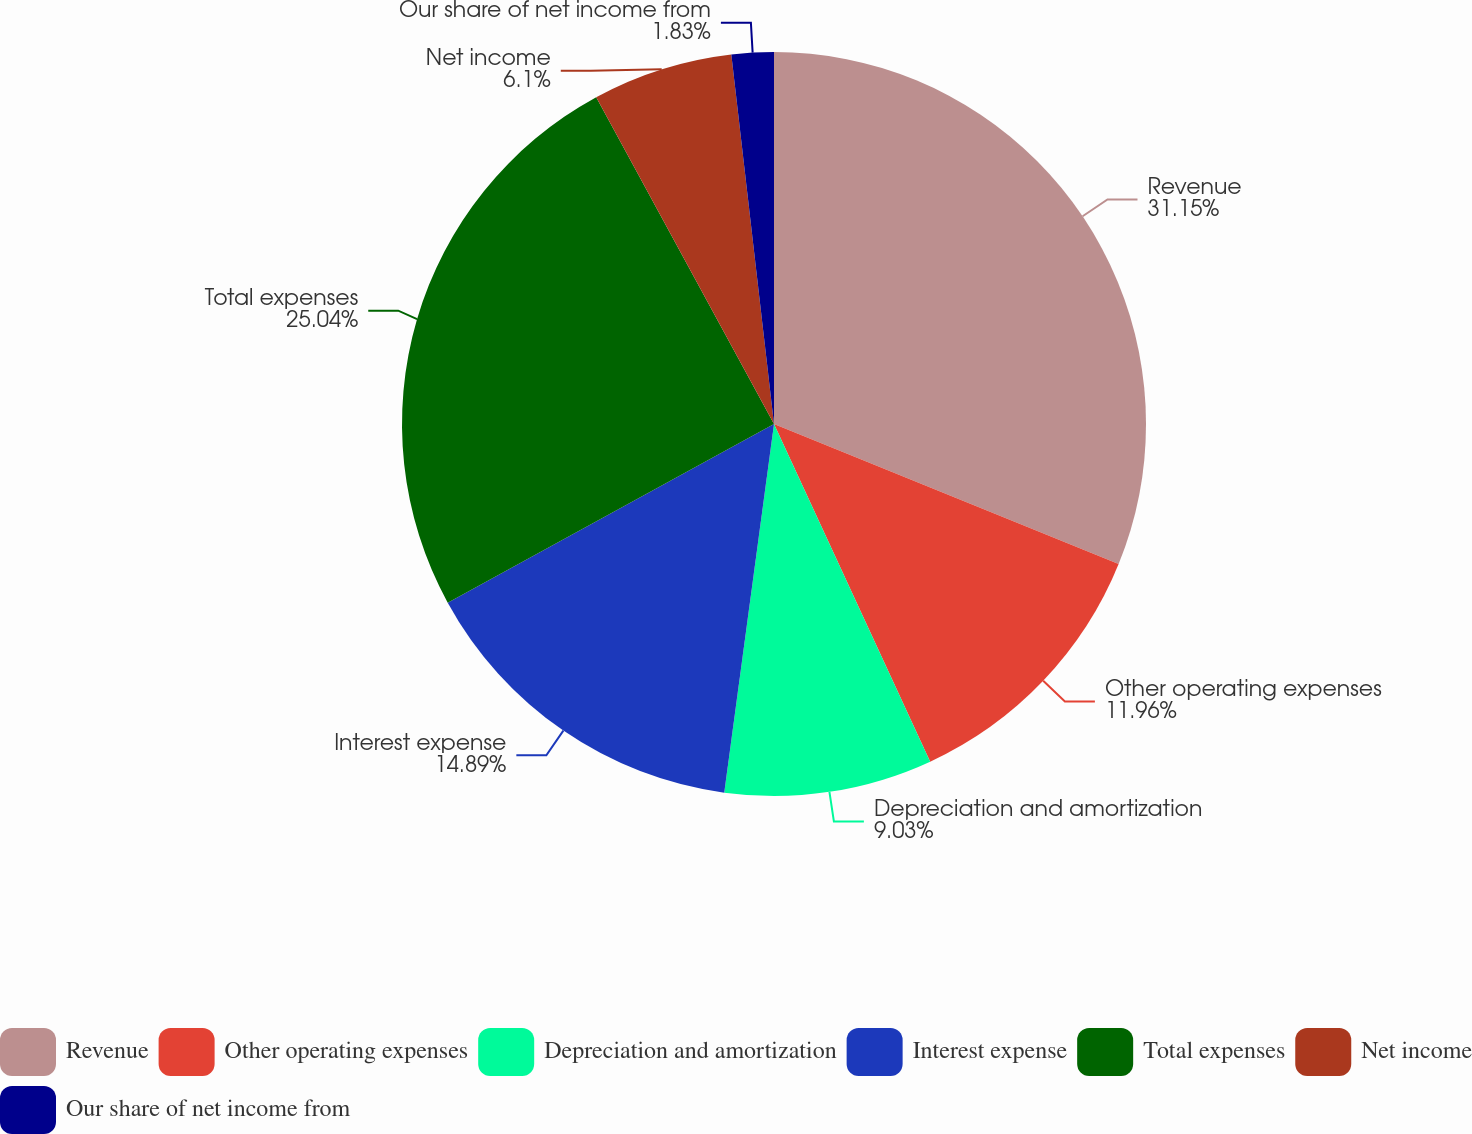<chart> <loc_0><loc_0><loc_500><loc_500><pie_chart><fcel>Revenue<fcel>Other operating expenses<fcel>Depreciation and amortization<fcel>Interest expense<fcel>Total expenses<fcel>Net income<fcel>Our share of net income from<nl><fcel>31.14%<fcel>11.96%<fcel>9.03%<fcel>14.89%<fcel>25.04%<fcel>6.1%<fcel>1.83%<nl></chart> 